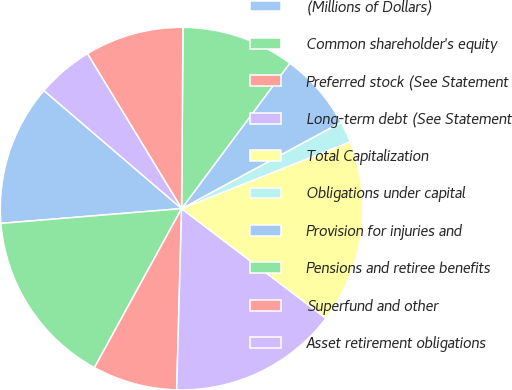Convert chart. <chart><loc_0><loc_0><loc_500><loc_500><pie_chart><fcel>(Millions of Dollars)<fcel>Common shareholder's equity<fcel>Preferred stock (See Statement<fcel>Long-term debt (See Statement<fcel>Total Capitalization<fcel>Obligations under capital<fcel>Provision for injuries and<fcel>Pensions and retiree benefits<fcel>Superfund and other<fcel>Asset retirement obligations<nl><fcel>12.58%<fcel>15.72%<fcel>7.55%<fcel>15.09%<fcel>16.35%<fcel>1.89%<fcel>6.92%<fcel>10.06%<fcel>8.81%<fcel>5.03%<nl></chart> 